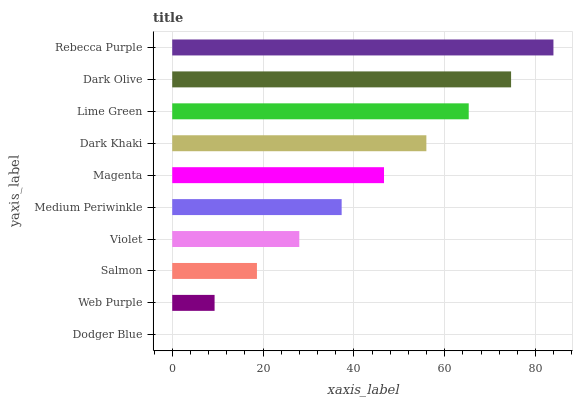Is Dodger Blue the minimum?
Answer yes or no. Yes. Is Rebecca Purple the maximum?
Answer yes or no. Yes. Is Web Purple the minimum?
Answer yes or no. No. Is Web Purple the maximum?
Answer yes or no. No. Is Web Purple greater than Dodger Blue?
Answer yes or no. Yes. Is Dodger Blue less than Web Purple?
Answer yes or no. Yes. Is Dodger Blue greater than Web Purple?
Answer yes or no. No. Is Web Purple less than Dodger Blue?
Answer yes or no. No. Is Magenta the high median?
Answer yes or no. Yes. Is Medium Periwinkle the low median?
Answer yes or no. Yes. Is Web Purple the high median?
Answer yes or no. No. Is Lime Green the low median?
Answer yes or no. No. 